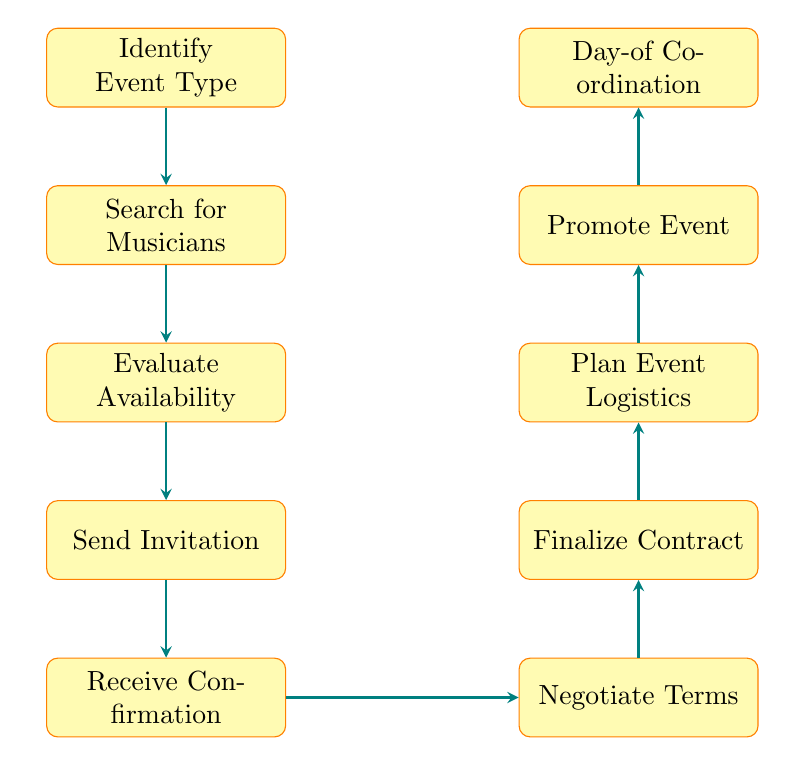What is the first step in the event invitation process? The flow chart starts with the node labeled "Identify Event Type", indicating that this is the initial action to take when beginning the invitation process for musicians.
Answer: Identify Event Type How many main steps are shown in the diagram? The diagram contains ten nodes, each representing a specific step in the event invitation process, from identifying the event type to day-of coordination.
Answer: Ten What step directly follows sending the invitation? According to the flow of the diagram, the step that follows "Send Invitation" is "Receive Confirmation", which indicates awaiting responses from the musicians invited.
Answer: Receive Confirmation What is the last step in the process? The final node at the top of the diagram is labeled "Day-of Coordination", suggesting that this is the concluding step that ensures the event runs smoothly on the scheduled day.
Answer: Day-of Coordination If the musicians are unavailable, which step might be revisited? If musicians are not available after the "Evaluate Availability" step, it may necessitate revisiting the "Search for Musicians" step to find other potential participants for the event.
Answer: Search for Musicians Which two steps can be conducted simultaneously if necessary? The "Negotiate Terms" and "Finalize Contract" steps can often be done in parallel since agreeing on terms may lead directly to drafting a contract, depending on prior agreements or mutual understanding.
Answer: Negotiate Terms and Finalize Contract Before promoting the event, which logistical aspect must be addressed? The "Plan Event Logistics" step occurs before the "Promote Event" step, indicating that organizing all necessary logistics should be completed to ensure effective promotion.
Answer: Plan Event Logistics What type of events are considered in this process? The first node mentions determining the event type which could be either a Luau, Festival, or Private Party as suitable categories for Hawaiian music events.
Answer: Luau, Festival, Private Party Which step involves preparing for accommodations? The node "Plan Event Logistics" addresses the organization of sound systems, stage setup, and also accommodations which covers the overall logistical planning needed for the musicians.
Answer: Plan Event Logistics 